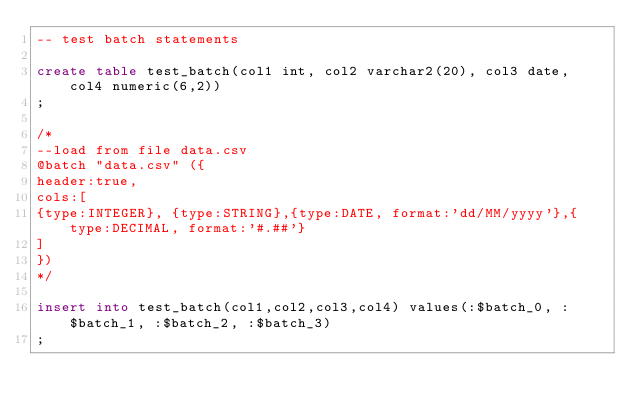<code> <loc_0><loc_0><loc_500><loc_500><_SQL_>-- test batch statements

create table test_batch(col1 int, col2 varchar2(20), col3 date, col4 numeric(6,2))
;

/*
--load from file data.csv
@batch "data.csv" ({
header:true,
cols:[
{type:INTEGER}, {type:STRING},{type:DATE, format:'dd/MM/yyyy'},{type:DECIMAL, format:'#.##'}
]
})
*/

insert into test_batch(col1,col2,col3,col4) values(:$batch_0, :$batch_1, :$batch_2, :$batch_3)
;


</code> 